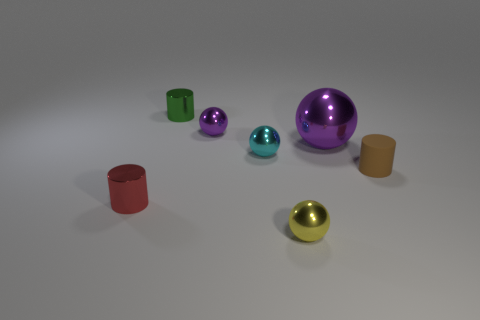Subtract all large purple shiny balls. How many balls are left? 3 Subtract all yellow balls. How many balls are left? 3 Add 2 purple spheres. How many objects exist? 9 Subtract all red cylinders. Subtract all gray cubes. How many cylinders are left? 2 Subtract all yellow cylinders. How many brown balls are left? 0 Subtract all yellow rubber spheres. Subtract all brown matte things. How many objects are left? 6 Add 4 tiny balls. How many tiny balls are left? 7 Add 3 cyan metal cubes. How many cyan metal cubes exist? 3 Subtract 1 brown cylinders. How many objects are left? 6 Subtract all balls. How many objects are left? 3 